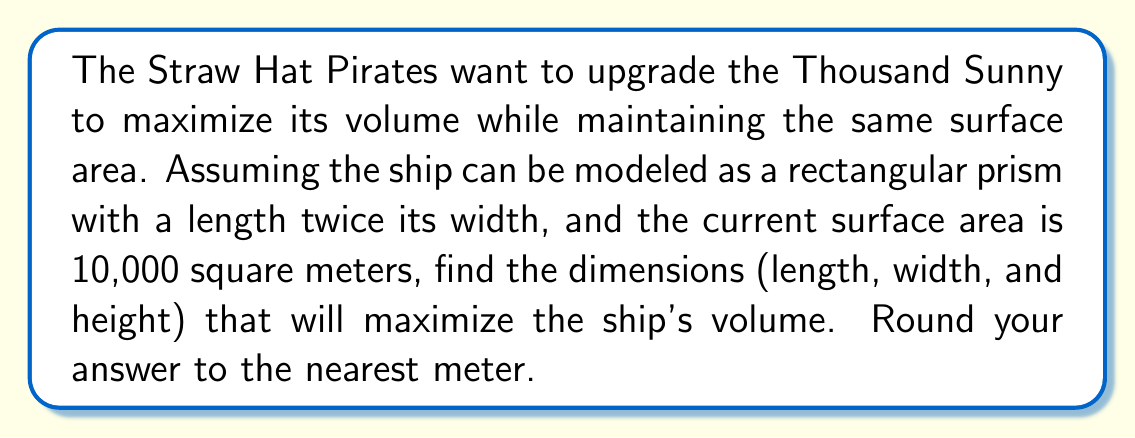Provide a solution to this math problem. Let's approach this step-by-step using optimization techniques:

1) Let the width be $w$, length be $2w$, and height be $h$.

2) The surface area formula for a rectangular prism is:
   $$ SA = 2lw + 2lh + 2wh $$

3) Substituting our known values:
   $$ 10000 = 2(2w)w + 2(2w)h + 2wh $$
   $$ 10000 = 4w^2 + 4wh + 2wh $$
   $$ 10000 = 4w^2 + 6wh $$

4) Solve for $h$:
   $$ h = \frac{10000 - 4w^2}{6w} $$

5) The volume formula is:
   $$ V = lwh = 2w \cdot w \cdot h = 2w^2h $$

6) Substitute the expression for $h$:
   $$ V = 2w^2 \cdot \frac{10000 - 4w^2}{6w} $$
   $$ V = \frac{2w(10000 - 4w^2)}{6} $$
   $$ V = \frac{20000w - 8w^3}{6} $$

7) To find the maximum, differentiate $V$ with respect to $w$ and set it to zero:
   $$ \frac{dV}{dw} = \frac{20000 - 24w^2}{6} = 0 $$
   $$ 20000 - 24w^2 = 0 $$
   $$ 24w^2 = 20000 $$
   $$ w^2 = \frac{20000}{24} \approx 833.33 $$
   $$ w \approx 28.87 $$

8) The length is twice the width, so $l \approx 57.74$

9) To find $h$, substitute $w$ back into the equation from step 4:
   $$ h = \frac{10000 - 4(28.87)^2}{6(28.87)} \approx 28.87 $$

10) Rounding to the nearest meter:
    Width $\approx 29$ m, Length $\approx 58$ m, Height $\approx 29$ m
Answer: The dimensions that maximize the Thousand Sunny's volume are approximately:
Length: 58 meters
Width: 29 meters
Height: 29 meters 